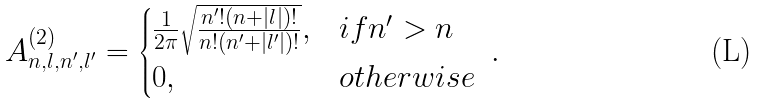<formula> <loc_0><loc_0><loc_500><loc_500>A ^ { ( 2 ) } _ { n , l , n ^ { \prime } , l ^ { \prime } } = \begin{cases} \frac { 1 } { 2 \pi } \sqrt { \frac { n ^ { \prime } ! ( n + | l | ) ! } { n ! ( n ^ { \prime } + | l ^ { \prime } | ) ! } } , & i f n ^ { \prime } > n \\ 0 , & o t h e r w i s e \end{cases} \ .</formula> 